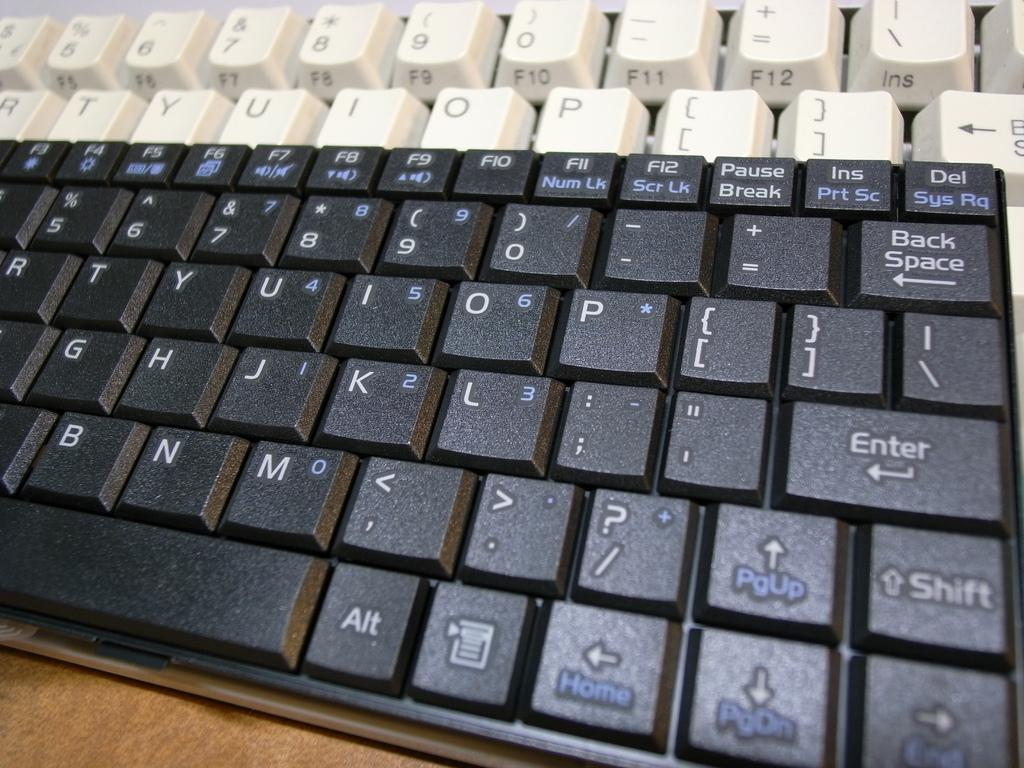<image>
Present a compact description of the photo's key features. A black keyboard has the home key on the same key as the left arrow. 